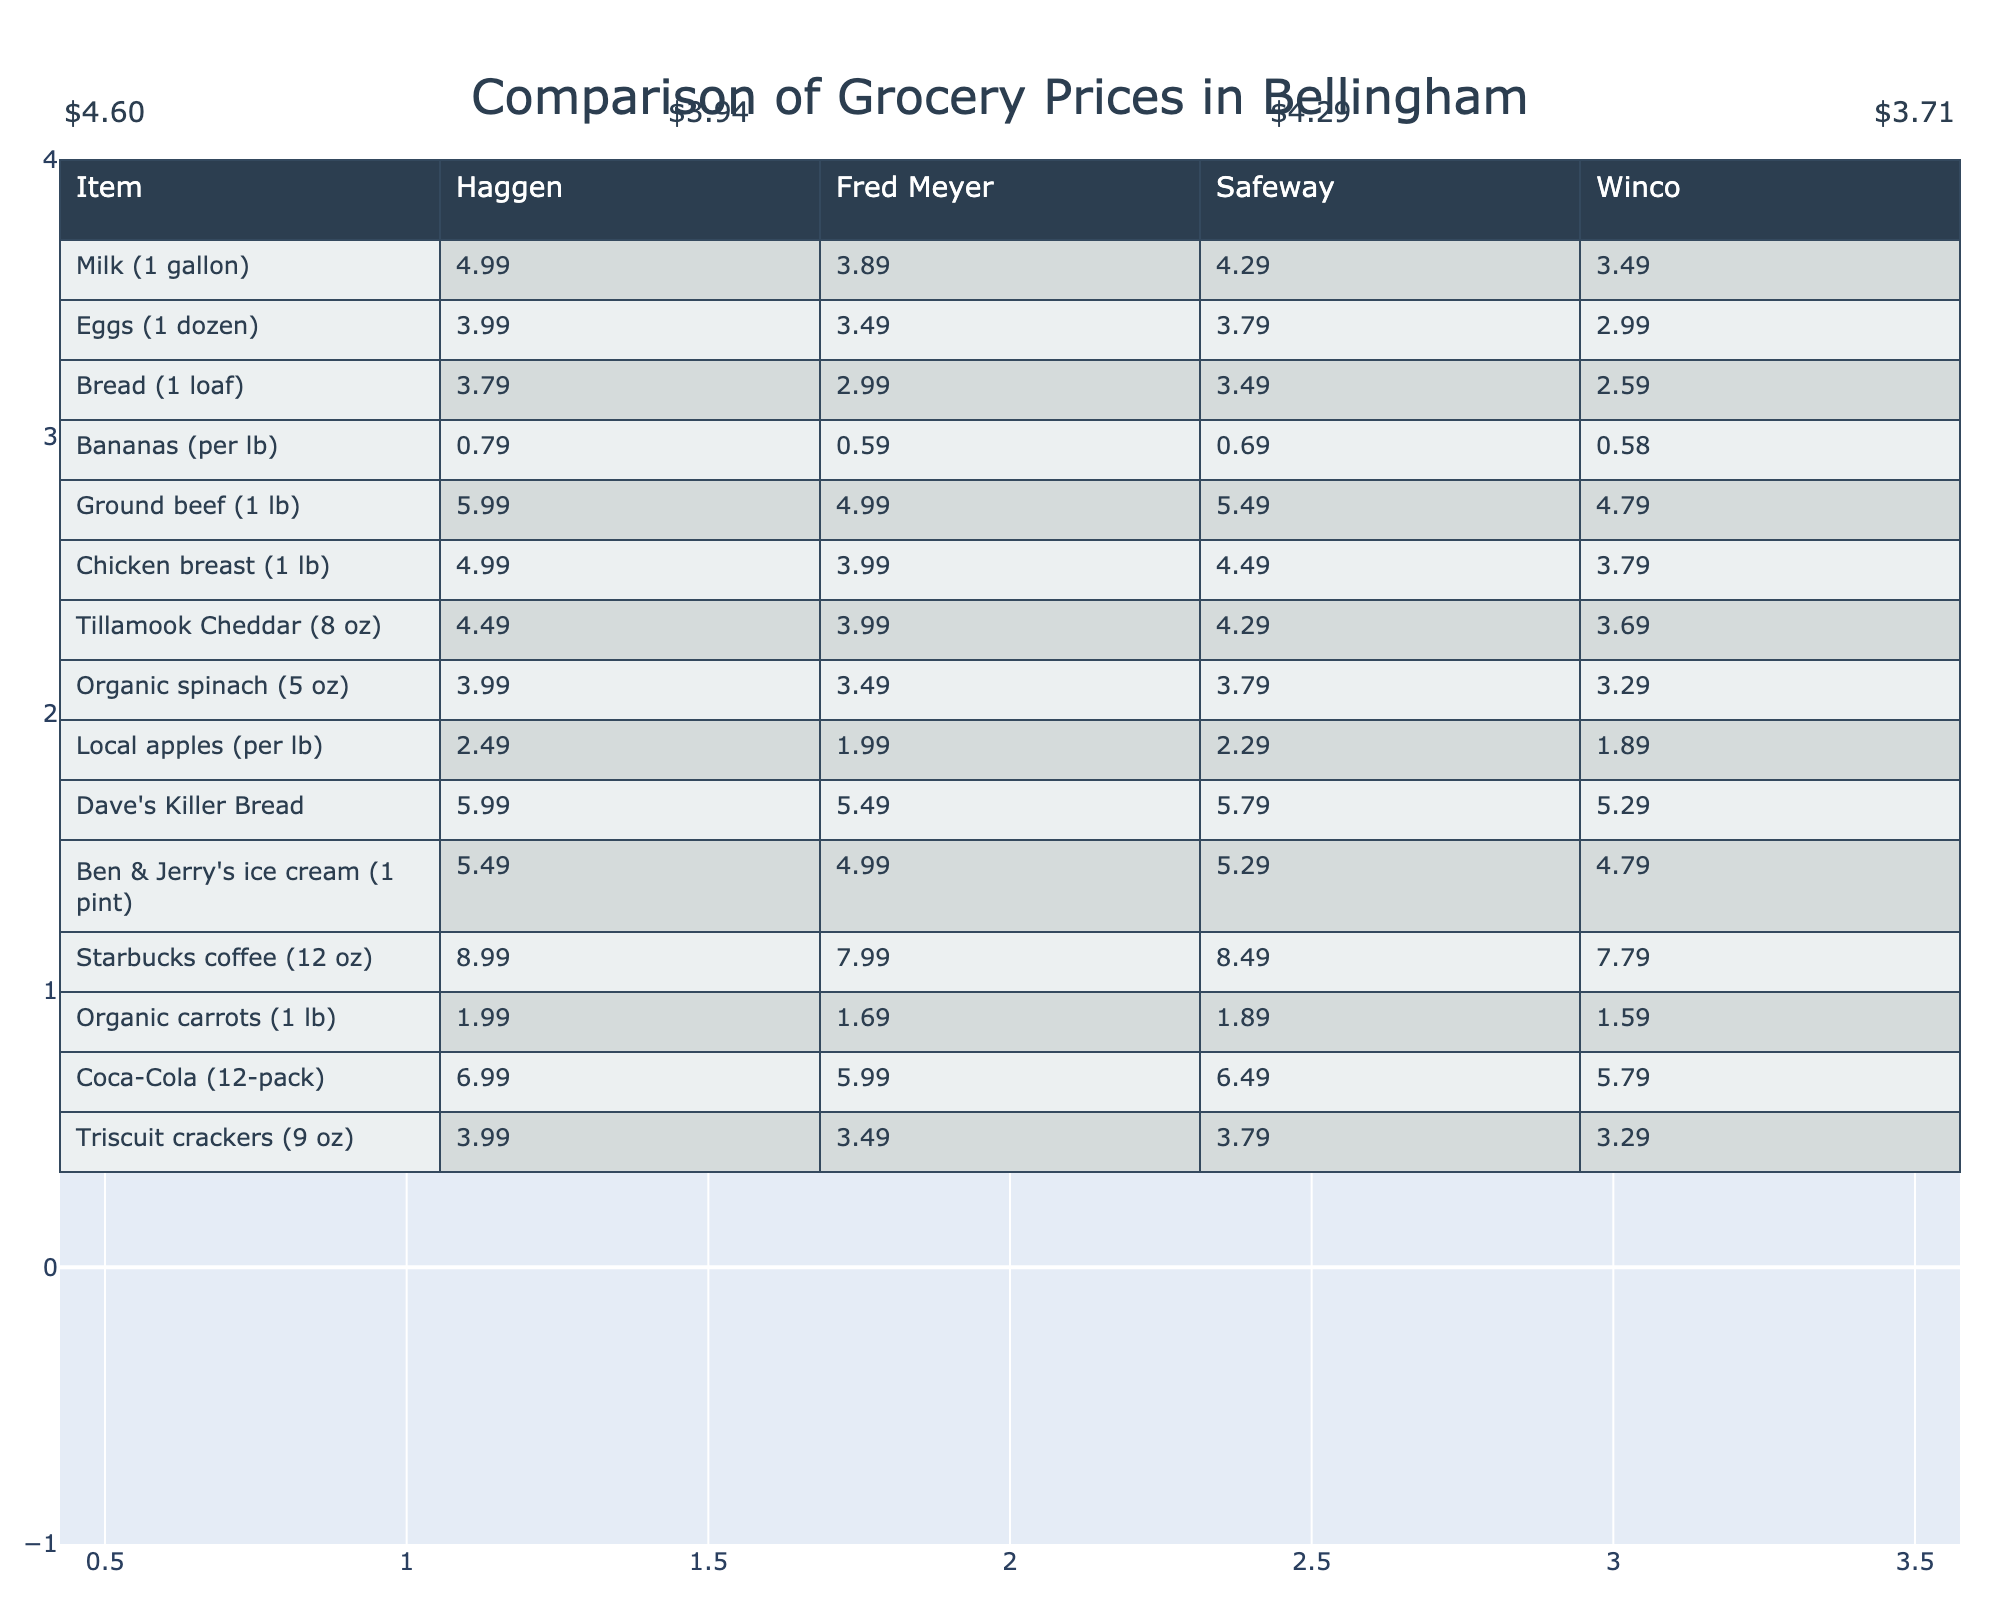What is the price of Milk (1 gallon) at Haggen? The table specifies the price for Milk (1 gallon) under the Haggen column, which is listed as 4.99.
Answer: 4.99 How much do Eggs (1 dozen) cost at Safeway? By checking the Safeway column for Eggs (1 dozen), the price is given as 3.79.
Answer: 3.79 Which store offers the lowest price for Bread (1 loaf)? To determine this, I look at the prices for Bread (1 loaf) across all stores: Haggen (3.79), Fred Meyer (2.99), Safeway (3.49), and Winco (2.59). Winco offers the lowest price at 2.59.
Answer: Winco What is the difference in price between Ground beef (1 lb) at Haggen and Winco? For Ground beef (1 lb): Haggen charges 5.99 and Winco charges 4.79. The difference is 5.99 - 4.79 = 1.20.
Answer: 1.20 Which store has the highest price for Starbucks coffee (12 oz)? The prices for Starbucks coffee (12 oz) are: Haggen (8.99), Fred Meyer (7.99), Safeway (8.49), and Winco (7.79). The highest price is at Haggen at 8.99.
Answer: Haggen What is the average price of organic carrots (1 lb) across all stores? The prices for organic carrots (1 lb) are: Haggen (1.99), Fred Meyer (1.69), Safeway (1.89), and Winco (1.59). The sum is 1.99 + 1.69 + 1.89 + 1.59 = 7.16. There are 4 prices, so the average is 7.16 / 4 = 1.79.
Answer: 1.79 Is it true that Ben & Jerry's ice cream (1 pint) is cheaper at Fred Meyer than at Haggen? The prices are: Haggen (5.49) and Fred Meyer (4.99). Since 4.99 is less than 5.49, this statement is true.
Answer: Yes What is the total cost for purchasing 2 lbs of Bananas at Winco? The price of Bananas at Winco is 0.58 per pound. Therefore, for 2 lbs, the cost would be 0.58 * 2 = 1.16.
Answer: 1.16 Which item has the highest price at all stores combined, and what is that price? Analyzing the highest price for each item from each store allows us to determine the overall highest. The highest item price is Starbucks coffee at Haggen for 8.99.
Answer: 8.99 Are local apples more expensive at Safeway than at Winco? The prices for local apples are: Safeway (2.29) and Winco (1.89). Since 2.29 is greater than 1.89, this is true.
Answer: Yes 